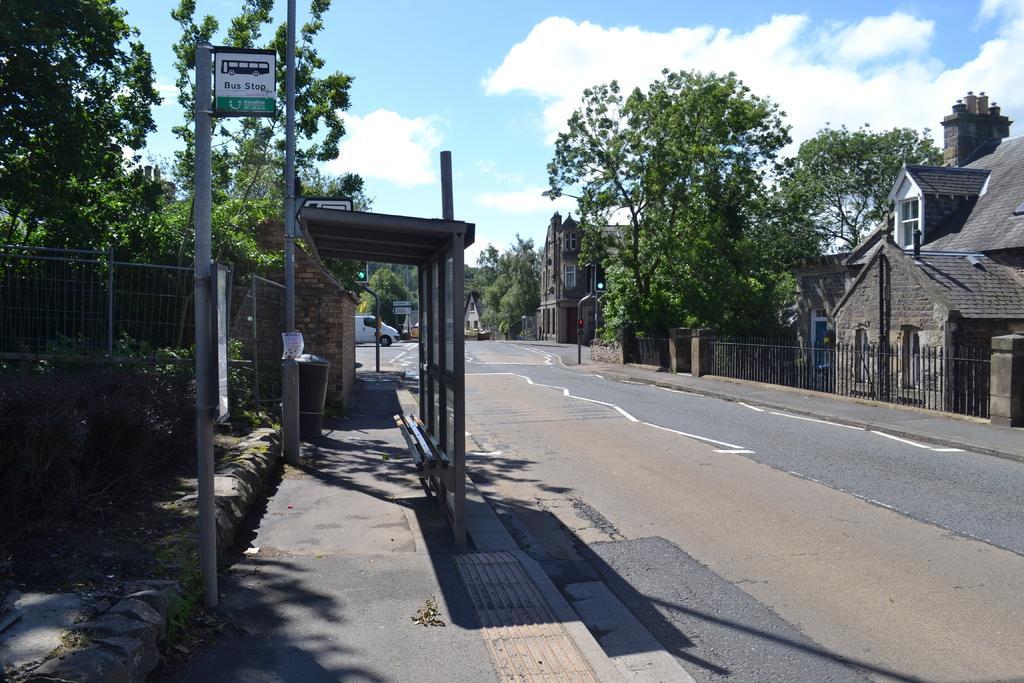Please provide a concise description of this image. In this picture I can see few buildings, trees and I can see a bus stop and a board with some text and I can see poles and a vehicle on the road and I can see blue cloudy sky. 